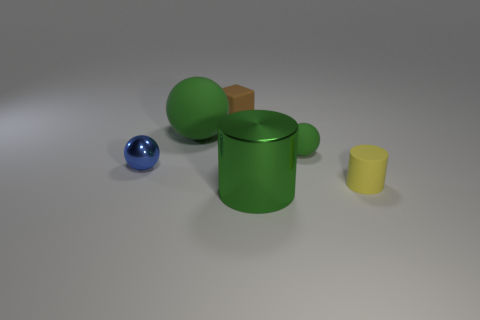How does the lighting in the scene affect the appearance of the objects? The lighting in the scene is soft and diffused, creating gentle shadows and subtle reflections on the objects. This contributes to a calm and balanced atmosphere, emphasizing the texture and color of each item. 